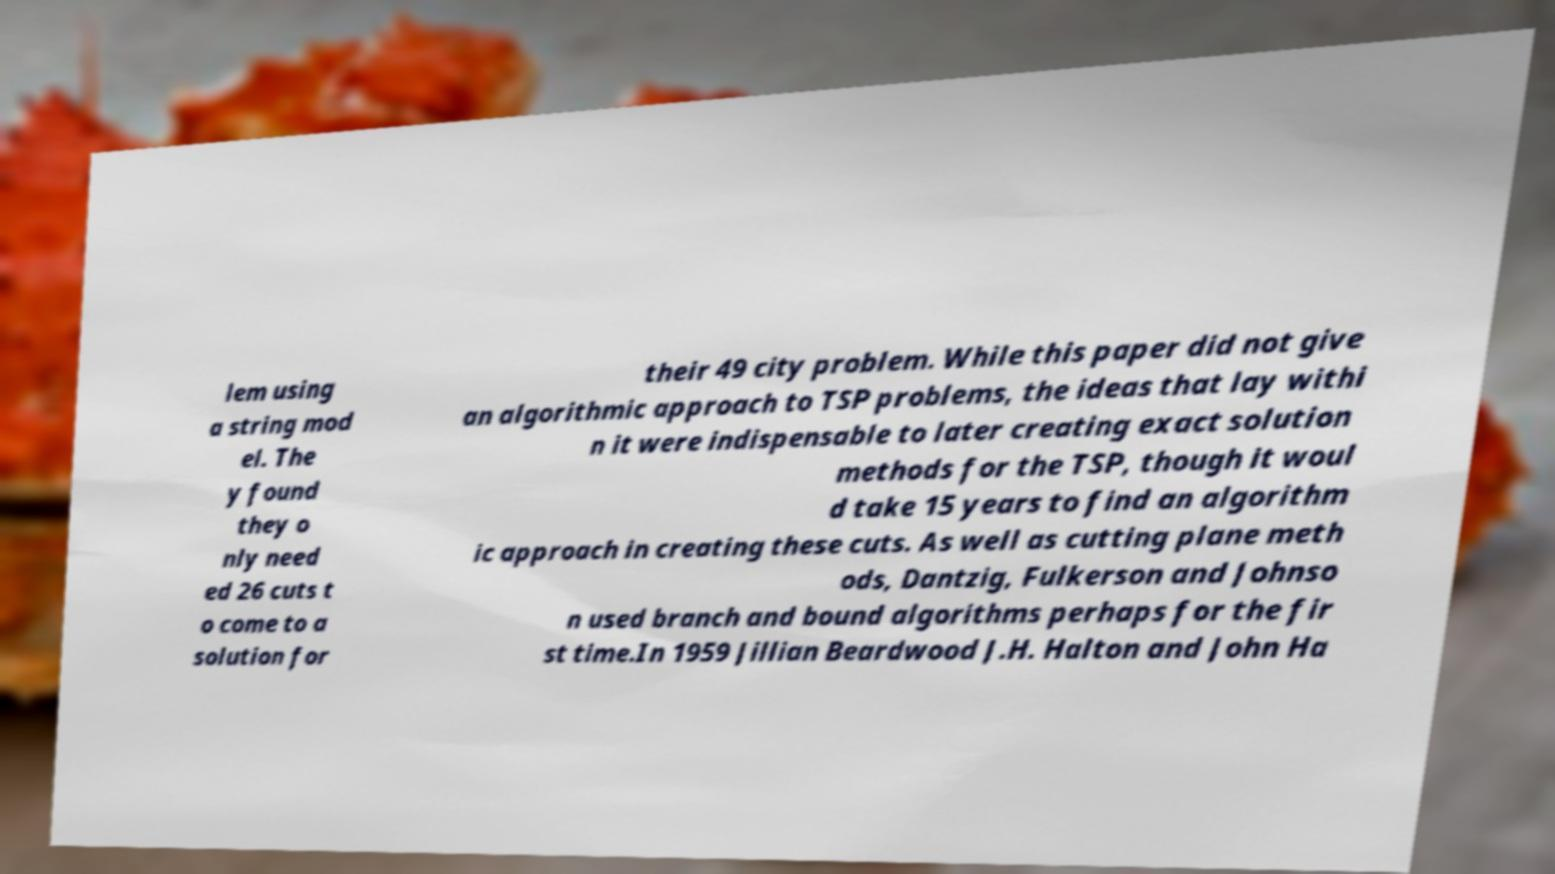What messages or text are displayed in this image? I need them in a readable, typed format. lem using a string mod el. The y found they o nly need ed 26 cuts t o come to a solution for their 49 city problem. While this paper did not give an algorithmic approach to TSP problems, the ideas that lay withi n it were indispensable to later creating exact solution methods for the TSP, though it woul d take 15 years to find an algorithm ic approach in creating these cuts. As well as cutting plane meth ods, Dantzig, Fulkerson and Johnso n used branch and bound algorithms perhaps for the fir st time.In 1959 Jillian Beardwood J.H. Halton and John Ha 